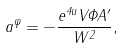<formula> <loc_0><loc_0><loc_500><loc_500>a ^ { \varphi } = - \frac { e ^ { 4 u } V \Phi A ^ { \prime } } { W ^ { 2 } } ,</formula> 